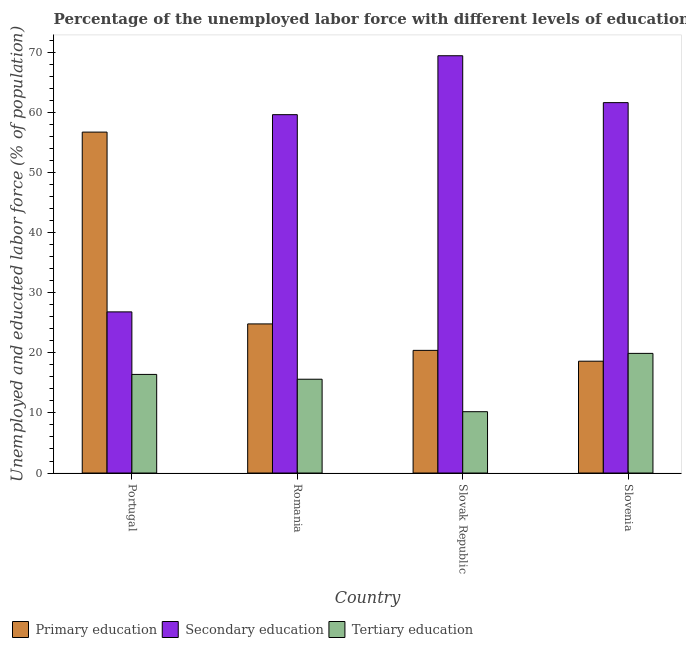How many groups of bars are there?
Ensure brevity in your answer.  4. Are the number of bars on each tick of the X-axis equal?
Offer a terse response. Yes. What is the label of the 4th group of bars from the left?
Your response must be concise. Slovenia. In how many cases, is the number of bars for a given country not equal to the number of legend labels?
Your response must be concise. 0. What is the percentage of labor force who received primary education in Romania?
Offer a very short reply. 24.8. Across all countries, what is the maximum percentage of labor force who received primary education?
Make the answer very short. 56.7. Across all countries, what is the minimum percentage of labor force who received secondary education?
Ensure brevity in your answer.  26.8. In which country was the percentage of labor force who received primary education minimum?
Your response must be concise. Slovenia. What is the total percentage of labor force who received primary education in the graph?
Your response must be concise. 120.5. What is the difference between the percentage of labor force who received primary education in Portugal and that in Slovak Republic?
Make the answer very short. 36.3. What is the difference between the percentage of labor force who received primary education in Slovak Republic and the percentage of labor force who received secondary education in Romania?
Provide a succinct answer. -39.2. What is the average percentage of labor force who received tertiary education per country?
Keep it short and to the point. 15.52. What is the difference between the percentage of labor force who received primary education and percentage of labor force who received tertiary education in Slovenia?
Your answer should be very brief. -1.3. In how many countries, is the percentage of labor force who received tertiary education greater than 18 %?
Your answer should be compact. 1. What is the ratio of the percentage of labor force who received secondary education in Romania to that in Slovenia?
Give a very brief answer. 0.97. Is the difference between the percentage of labor force who received secondary education in Portugal and Slovenia greater than the difference between the percentage of labor force who received tertiary education in Portugal and Slovenia?
Make the answer very short. No. What is the difference between the highest and the second highest percentage of labor force who received primary education?
Offer a very short reply. 31.9. What is the difference between the highest and the lowest percentage of labor force who received secondary education?
Offer a very short reply. 42.6. What does the 1st bar from the left in Slovenia represents?
Offer a very short reply. Primary education. What does the 1st bar from the right in Slovak Republic represents?
Offer a very short reply. Tertiary education. Is it the case that in every country, the sum of the percentage of labor force who received primary education and percentage of labor force who received secondary education is greater than the percentage of labor force who received tertiary education?
Offer a very short reply. Yes. How many bars are there?
Provide a short and direct response. 12. Are all the bars in the graph horizontal?
Your answer should be compact. No. Does the graph contain any zero values?
Offer a terse response. No. Does the graph contain grids?
Keep it short and to the point. No. Where does the legend appear in the graph?
Offer a very short reply. Bottom left. How are the legend labels stacked?
Your response must be concise. Horizontal. What is the title of the graph?
Your answer should be compact. Percentage of the unemployed labor force with different levels of education in countries. Does "Secondary education" appear as one of the legend labels in the graph?
Offer a very short reply. Yes. What is the label or title of the Y-axis?
Offer a terse response. Unemployed and educated labor force (% of population). What is the Unemployed and educated labor force (% of population) of Primary education in Portugal?
Make the answer very short. 56.7. What is the Unemployed and educated labor force (% of population) in Secondary education in Portugal?
Your answer should be very brief. 26.8. What is the Unemployed and educated labor force (% of population) in Tertiary education in Portugal?
Provide a short and direct response. 16.4. What is the Unemployed and educated labor force (% of population) of Primary education in Romania?
Make the answer very short. 24.8. What is the Unemployed and educated labor force (% of population) of Secondary education in Romania?
Make the answer very short. 59.6. What is the Unemployed and educated labor force (% of population) of Tertiary education in Romania?
Make the answer very short. 15.6. What is the Unemployed and educated labor force (% of population) of Primary education in Slovak Republic?
Your answer should be very brief. 20.4. What is the Unemployed and educated labor force (% of population) in Secondary education in Slovak Republic?
Offer a terse response. 69.4. What is the Unemployed and educated labor force (% of population) of Tertiary education in Slovak Republic?
Keep it short and to the point. 10.2. What is the Unemployed and educated labor force (% of population) of Primary education in Slovenia?
Make the answer very short. 18.6. What is the Unemployed and educated labor force (% of population) in Secondary education in Slovenia?
Your answer should be very brief. 61.6. What is the Unemployed and educated labor force (% of population) in Tertiary education in Slovenia?
Provide a short and direct response. 19.9. Across all countries, what is the maximum Unemployed and educated labor force (% of population) of Primary education?
Your answer should be compact. 56.7. Across all countries, what is the maximum Unemployed and educated labor force (% of population) of Secondary education?
Provide a succinct answer. 69.4. Across all countries, what is the maximum Unemployed and educated labor force (% of population) of Tertiary education?
Provide a succinct answer. 19.9. Across all countries, what is the minimum Unemployed and educated labor force (% of population) in Primary education?
Ensure brevity in your answer.  18.6. Across all countries, what is the minimum Unemployed and educated labor force (% of population) in Secondary education?
Make the answer very short. 26.8. Across all countries, what is the minimum Unemployed and educated labor force (% of population) of Tertiary education?
Give a very brief answer. 10.2. What is the total Unemployed and educated labor force (% of population) in Primary education in the graph?
Your answer should be compact. 120.5. What is the total Unemployed and educated labor force (% of population) of Secondary education in the graph?
Offer a very short reply. 217.4. What is the total Unemployed and educated labor force (% of population) in Tertiary education in the graph?
Ensure brevity in your answer.  62.1. What is the difference between the Unemployed and educated labor force (% of population) of Primary education in Portugal and that in Romania?
Provide a short and direct response. 31.9. What is the difference between the Unemployed and educated labor force (% of population) in Secondary education in Portugal and that in Romania?
Your answer should be compact. -32.8. What is the difference between the Unemployed and educated labor force (% of population) of Primary education in Portugal and that in Slovak Republic?
Offer a terse response. 36.3. What is the difference between the Unemployed and educated labor force (% of population) of Secondary education in Portugal and that in Slovak Republic?
Provide a short and direct response. -42.6. What is the difference between the Unemployed and educated labor force (% of population) of Primary education in Portugal and that in Slovenia?
Your answer should be very brief. 38.1. What is the difference between the Unemployed and educated labor force (% of population) in Secondary education in Portugal and that in Slovenia?
Your answer should be very brief. -34.8. What is the difference between the Unemployed and educated labor force (% of population) in Primary education in Romania and that in Slovak Republic?
Give a very brief answer. 4.4. What is the difference between the Unemployed and educated labor force (% of population) in Secondary education in Romania and that in Slovak Republic?
Your response must be concise. -9.8. What is the difference between the Unemployed and educated labor force (% of population) of Tertiary education in Romania and that in Slovenia?
Your answer should be very brief. -4.3. What is the difference between the Unemployed and educated labor force (% of population) in Primary education in Slovak Republic and that in Slovenia?
Make the answer very short. 1.8. What is the difference between the Unemployed and educated labor force (% of population) of Secondary education in Slovak Republic and that in Slovenia?
Provide a short and direct response. 7.8. What is the difference between the Unemployed and educated labor force (% of population) in Tertiary education in Slovak Republic and that in Slovenia?
Your answer should be very brief. -9.7. What is the difference between the Unemployed and educated labor force (% of population) of Primary education in Portugal and the Unemployed and educated labor force (% of population) of Secondary education in Romania?
Offer a very short reply. -2.9. What is the difference between the Unemployed and educated labor force (% of population) in Primary education in Portugal and the Unemployed and educated labor force (% of population) in Tertiary education in Romania?
Offer a terse response. 41.1. What is the difference between the Unemployed and educated labor force (% of population) of Primary education in Portugal and the Unemployed and educated labor force (% of population) of Secondary education in Slovak Republic?
Provide a short and direct response. -12.7. What is the difference between the Unemployed and educated labor force (% of population) in Primary education in Portugal and the Unemployed and educated labor force (% of population) in Tertiary education in Slovak Republic?
Give a very brief answer. 46.5. What is the difference between the Unemployed and educated labor force (% of population) of Primary education in Portugal and the Unemployed and educated labor force (% of population) of Tertiary education in Slovenia?
Give a very brief answer. 36.8. What is the difference between the Unemployed and educated labor force (% of population) in Primary education in Romania and the Unemployed and educated labor force (% of population) in Secondary education in Slovak Republic?
Your answer should be compact. -44.6. What is the difference between the Unemployed and educated labor force (% of population) in Primary education in Romania and the Unemployed and educated labor force (% of population) in Tertiary education in Slovak Republic?
Offer a terse response. 14.6. What is the difference between the Unemployed and educated labor force (% of population) of Secondary education in Romania and the Unemployed and educated labor force (% of population) of Tertiary education in Slovak Republic?
Your answer should be very brief. 49.4. What is the difference between the Unemployed and educated labor force (% of population) of Primary education in Romania and the Unemployed and educated labor force (% of population) of Secondary education in Slovenia?
Provide a succinct answer. -36.8. What is the difference between the Unemployed and educated labor force (% of population) of Secondary education in Romania and the Unemployed and educated labor force (% of population) of Tertiary education in Slovenia?
Your answer should be compact. 39.7. What is the difference between the Unemployed and educated labor force (% of population) in Primary education in Slovak Republic and the Unemployed and educated labor force (% of population) in Secondary education in Slovenia?
Make the answer very short. -41.2. What is the difference between the Unemployed and educated labor force (% of population) in Secondary education in Slovak Republic and the Unemployed and educated labor force (% of population) in Tertiary education in Slovenia?
Make the answer very short. 49.5. What is the average Unemployed and educated labor force (% of population) of Primary education per country?
Ensure brevity in your answer.  30.12. What is the average Unemployed and educated labor force (% of population) in Secondary education per country?
Provide a succinct answer. 54.35. What is the average Unemployed and educated labor force (% of population) of Tertiary education per country?
Ensure brevity in your answer.  15.53. What is the difference between the Unemployed and educated labor force (% of population) of Primary education and Unemployed and educated labor force (% of population) of Secondary education in Portugal?
Provide a succinct answer. 29.9. What is the difference between the Unemployed and educated labor force (% of population) in Primary education and Unemployed and educated labor force (% of population) in Tertiary education in Portugal?
Ensure brevity in your answer.  40.3. What is the difference between the Unemployed and educated labor force (% of population) in Secondary education and Unemployed and educated labor force (% of population) in Tertiary education in Portugal?
Offer a very short reply. 10.4. What is the difference between the Unemployed and educated labor force (% of population) in Primary education and Unemployed and educated labor force (% of population) in Secondary education in Romania?
Offer a very short reply. -34.8. What is the difference between the Unemployed and educated labor force (% of population) of Secondary education and Unemployed and educated labor force (% of population) of Tertiary education in Romania?
Offer a terse response. 44. What is the difference between the Unemployed and educated labor force (% of population) of Primary education and Unemployed and educated labor force (% of population) of Secondary education in Slovak Republic?
Give a very brief answer. -49. What is the difference between the Unemployed and educated labor force (% of population) in Primary education and Unemployed and educated labor force (% of population) in Tertiary education in Slovak Republic?
Your response must be concise. 10.2. What is the difference between the Unemployed and educated labor force (% of population) in Secondary education and Unemployed and educated labor force (% of population) in Tertiary education in Slovak Republic?
Provide a short and direct response. 59.2. What is the difference between the Unemployed and educated labor force (% of population) of Primary education and Unemployed and educated labor force (% of population) of Secondary education in Slovenia?
Provide a succinct answer. -43. What is the difference between the Unemployed and educated labor force (% of population) in Primary education and Unemployed and educated labor force (% of population) in Tertiary education in Slovenia?
Give a very brief answer. -1.3. What is the difference between the Unemployed and educated labor force (% of population) of Secondary education and Unemployed and educated labor force (% of population) of Tertiary education in Slovenia?
Provide a succinct answer. 41.7. What is the ratio of the Unemployed and educated labor force (% of population) in Primary education in Portugal to that in Romania?
Provide a succinct answer. 2.29. What is the ratio of the Unemployed and educated labor force (% of population) of Secondary education in Portugal to that in Romania?
Offer a terse response. 0.45. What is the ratio of the Unemployed and educated labor force (% of population) in Tertiary education in Portugal to that in Romania?
Give a very brief answer. 1.05. What is the ratio of the Unemployed and educated labor force (% of population) in Primary education in Portugal to that in Slovak Republic?
Make the answer very short. 2.78. What is the ratio of the Unemployed and educated labor force (% of population) of Secondary education in Portugal to that in Slovak Republic?
Ensure brevity in your answer.  0.39. What is the ratio of the Unemployed and educated labor force (% of population) of Tertiary education in Portugal to that in Slovak Republic?
Offer a very short reply. 1.61. What is the ratio of the Unemployed and educated labor force (% of population) in Primary education in Portugal to that in Slovenia?
Give a very brief answer. 3.05. What is the ratio of the Unemployed and educated labor force (% of population) in Secondary education in Portugal to that in Slovenia?
Make the answer very short. 0.44. What is the ratio of the Unemployed and educated labor force (% of population) of Tertiary education in Portugal to that in Slovenia?
Provide a succinct answer. 0.82. What is the ratio of the Unemployed and educated labor force (% of population) in Primary education in Romania to that in Slovak Republic?
Give a very brief answer. 1.22. What is the ratio of the Unemployed and educated labor force (% of population) in Secondary education in Romania to that in Slovak Republic?
Provide a short and direct response. 0.86. What is the ratio of the Unemployed and educated labor force (% of population) in Tertiary education in Romania to that in Slovak Republic?
Your answer should be very brief. 1.53. What is the ratio of the Unemployed and educated labor force (% of population) of Secondary education in Romania to that in Slovenia?
Offer a very short reply. 0.97. What is the ratio of the Unemployed and educated labor force (% of population) of Tertiary education in Romania to that in Slovenia?
Provide a short and direct response. 0.78. What is the ratio of the Unemployed and educated labor force (% of population) in Primary education in Slovak Republic to that in Slovenia?
Make the answer very short. 1.1. What is the ratio of the Unemployed and educated labor force (% of population) of Secondary education in Slovak Republic to that in Slovenia?
Offer a very short reply. 1.13. What is the ratio of the Unemployed and educated labor force (% of population) in Tertiary education in Slovak Republic to that in Slovenia?
Your answer should be very brief. 0.51. What is the difference between the highest and the second highest Unemployed and educated labor force (% of population) in Primary education?
Your response must be concise. 31.9. What is the difference between the highest and the second highest Unemployed and educated labor force (% of population) of Secondary education?
Your answer should be very brief. 7.8. What is the difference between the highest and the second highest Unemployed and educated labor force (% of population) in Tertiary education?
Ensure brevity in your answer.  3.5. What is the difference between the highest and the lowest Unemployed and educated labor force (% of population) of Primary education?
Offer a very short reply. 38.1. What is the difference between the highest and the lowest Unemployed and educated labor force (% of population) of Secondary education?
Your response must be concise. 42.6. What is the difference between the highest and the lowest Unemployed and educated labor force (% of population) in Tertiary education?
Make the answer very short. 9.7. 